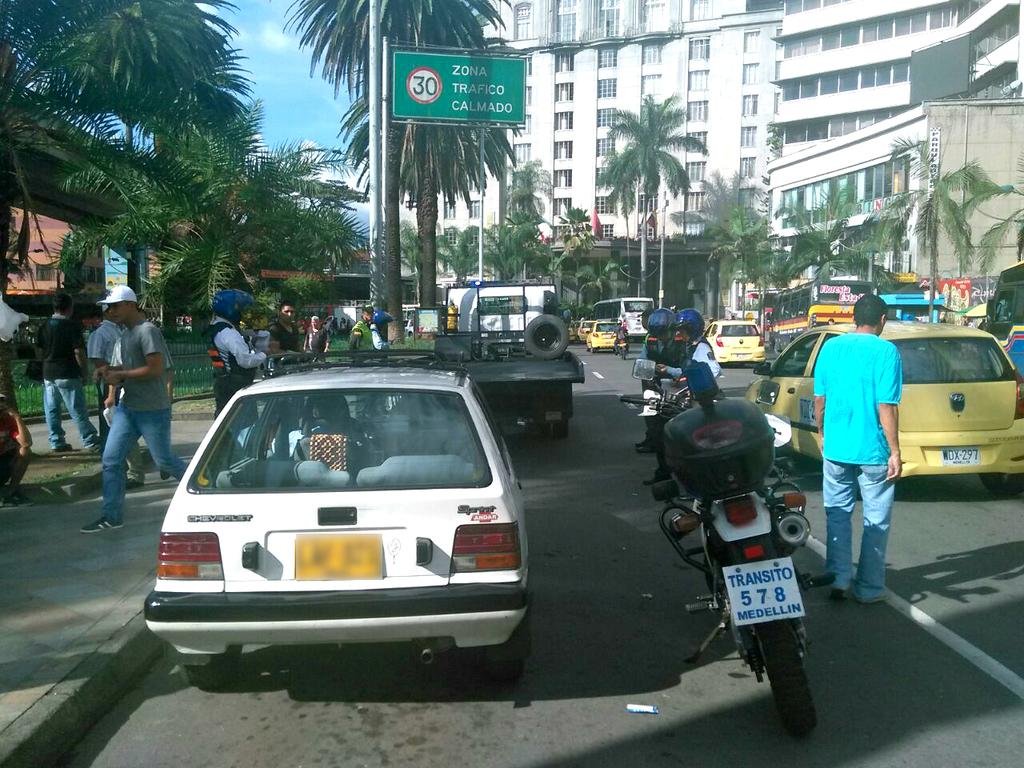Provide a one-sentence caption for the provided image. A motorcycle with plate number 578 is parked next to a white car along a busy city street with lots of pedestrians. 